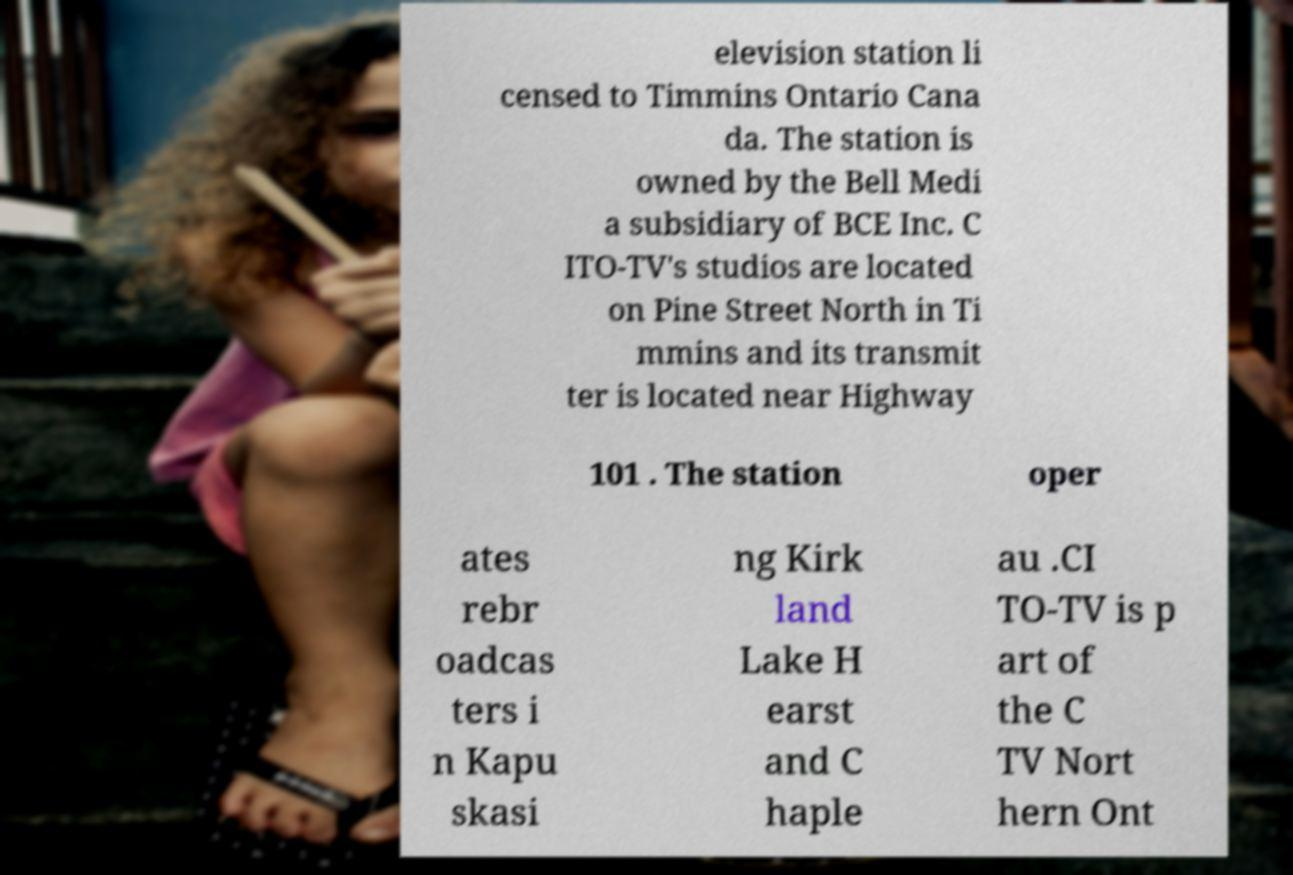Can you read and provide the text displayed in the image?This photo seems to have some interesting text. Can you extract and type it out for me? elevision station li censed to Timmins Ontario Cana da. The station is owned by the Bell Medi a subsidiary of BCE Inc. C ITO-TV's studios are located on Pine Street North in Ti mmins and its transmit ter is located near Highway 101 . The station oper ates rebr oadcas ters i n Kapu skasi ng Kirk land Lake H earst and C haple au .CI TO-TV is p art of the C TV Nort hern Ont 